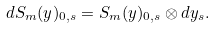Convert formula to latex. <formula><loc_0><loc_0><loc_500><loc_500>d S _ { m } ( y ) _ { 0 , s } = S _ { m } ( y ) _ { 0 , s } \otimes d y _ { s } .</formula> 